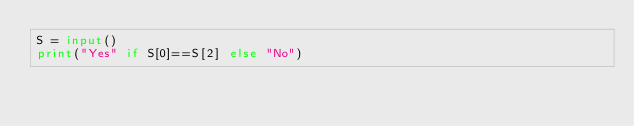<code> <loc_0><loc_0><loc_500><loc_500><_Python_>S = input()
print("Yes" if S[0]==S[2] else "No")</code> 